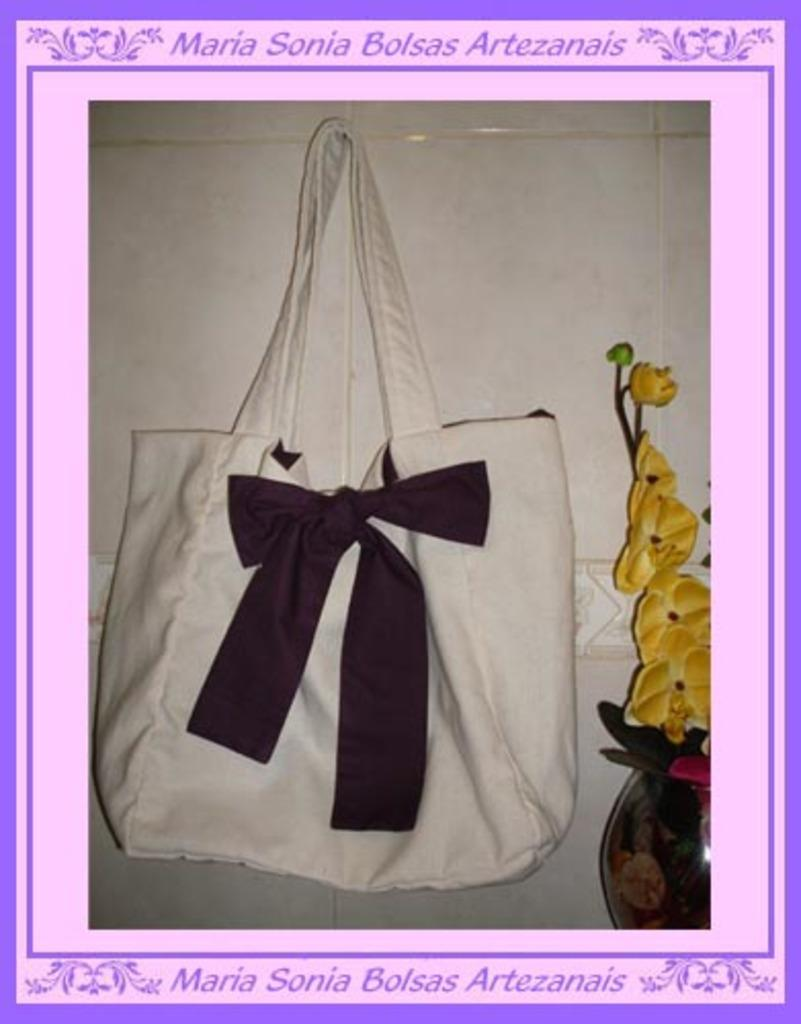What type of flooring is visible in the image? There are white color tiles in the image. What object can be seen in the image besides the tiles? There is a bag in the image. What type of decorative element is present in the image? There are flowers in the image. What day of the week is depicted in the image? There is no specific day of the week depicted in the image; it is a still image. 